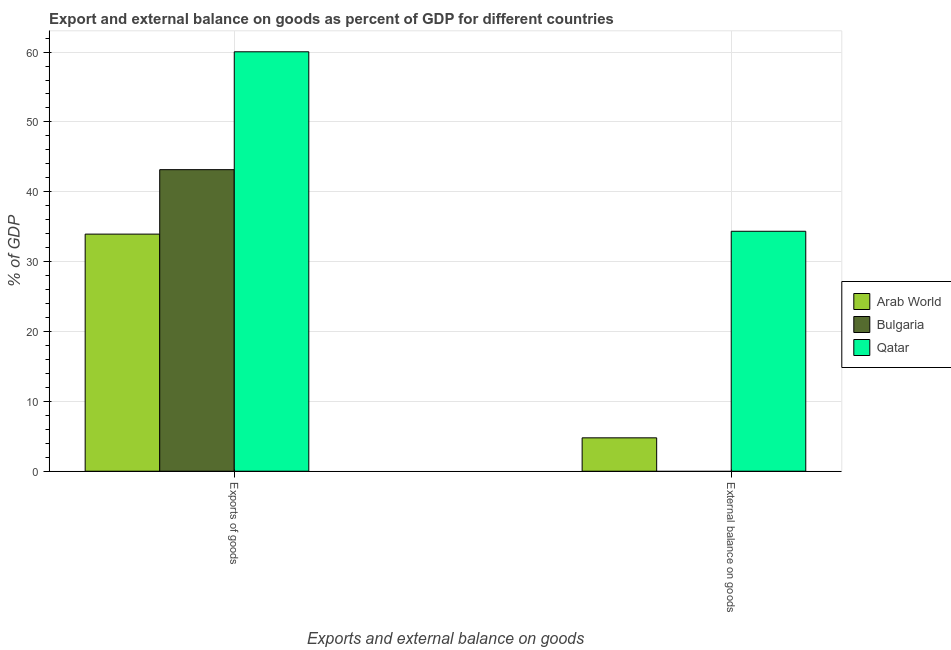How many different coloured bars are there?
Ensure brevity in your answer.  3. Are the number of bars per tick equal to the number of legend labels?
Provide a short and direct response. No. What is the label of the 1st group of bars from the left?
Offer a terse response. Exports of goods. What is the export of goods as percentage of gdp in Bulgaria?
Provide a succinct answer. 43.17. Across all countries, what is the maximum external balance on goods as percentage of gdp?
Ensure brevity in your answer.  34.35. In which country was the export of goods as percentage of gdp maximum?
Keep it short and to the point. Qatar. What is the total external balance on goods as percentage of gdp in the graph?
Your answer should be very brief. 39.13. What is the difference between the export of goods as percentage of gdp in Qatar and that in Bulgaria?
Provide a succinct answer. 16.87. What is the difference between the external balance on goods as percentage of gdp in Arab World and the export of goods as percentage of gdp in Bulgaria?
Make the answer very short. -38.39. What is the average export of goods as percentage of gdp per country?
Provide a short and direct response. 45.72. What is the difference between the external balance on goods as percentage of gdp and export of goods as percentage of gdp in Qatar?
Provide a short and direct response. -25.69. In how many countries, is the external balance on goods as percentage of gdp greater than 32 %?
Give a very brief answer. 1. What is the ratio of the export of goods as percentage of gdp in Arab World to that in Bulgaria?
Give a very brief answer. 0.79. Are the values on the major ticks of Y-axis written in scientific E-notation?
Provide a succinct answer. No. Does the graph contain any zero values?
Make the answer very short. Yes. How many legend labels are there?
Your answer should be very brief. 3. How are the legend labels stacked?
Provide a succinct answer. Vertical. What is the title of the graph?
Provide a short and direct response. Export and external balance on goods as percent of GDP for different countries. What is the label or title of the X-axis?
Your answer should be very brief. Exports and external balance on goods. What is the label or title of the Y-axis?
Offer a very short reply. % of GDP. What is the % of GDP of Arab World in Exports of goods?
Ensure brevity in your answer.  33.94. What is the % of GDP in Bulgaria in Exports of goods?
Provide a short and direct response. 43.17. What is the % of GDP of Qatar in Exports of goods?
Your response must be concise. 60.04. What is the % of GDP in Arab World in External balance on goods?
Give a very brief answer. 4.78. What is the % of GDP in Bulgaria in External balance on goods?
Offer a terse response. 0. What is the % of GDP of Qatar in External balance on goods?
Provide a succinct answer. 34.35. Across all Exports and external balance on goods, what is the maximum % of GDP in Arab World?
Your response must be concise. 33.94. Across all Exports and external balance on goods, what is the maximum % of GDP of Bulgaria?
Provide a succinct answer. 43.17. Across all Exports and external balance on goods, what is the maximum % of GDP of Qatar?
Offer a terse response. 60.04. Across all Exports and external balance on goods, what is the minimum % of GDP of Arab World?
Your response must be concise. 4.78. Across all Exports and external balance on goods, what is the minimum % of GDP in Qatar?
Your answer should be compact. 34.35. What is the total % of GDP of Arab World in the graph?
Your answer should be compact. 38.72. What is the total % of GDP of Bulgaria in the graph?
Provide a succinct answer. 43.17. What is the total % of GDP of Qatar in the graph?
Your answer should be very brief. 94.39. What is the difference between the % of GDP of Arab World in Exports of goods and that in External balance on goods?
Provide a short and direct response. 29.16. What is the difference between the % of GDP of Qatar in Exports of goods and that in External balance on goods?
Your answer should be very brief. 25.69. What is the difference between the % of GDP in Arab World in Exports of goods and the % of GDP in Qatar in External balance on goods?
Provide a short and direct response. -0.41. What is the difference between the % of GDP in Bulgaria in Exports of goods and the % of GDP in Qatar in External balance on goods?
Keep it short and to the point. 8.82. What is the average % of GDP in Arab World per Exports and external balance on goods?
Provide a succinct answer. 19.36. What is the average % of GDP in Bulgaria per Exports and external balance on goods?
Provide a short and direct response. 21.58. What is the average % of GDP in Qatar per Exports and external balance on goods?
Your response must be concise. 47.19. What is the difference between the % of GDP in Arab World and % of GDP in Bulgaria in Exports of goods?
Provide a succinct answer. -9.23. What is the difference between the % of GDP of Arab World and % of GDP of Qatar in Exports of goods?
Offer a terse response. -26.1. What is the difference between the % of GDP in Bulgaria and % of GDP in Qatar in Exports of goods?
Provide a succinct answer. -16.87. What is the difference between the % of GDP in Arab World and % of GDP in Qatar in External balance on goods?
Ensure brevity in your answer.  -29.57. What is the ratio of the % of GDP of Arab World in Exports of goods to that in External balance on goods?
Provide a succinct answer. 7.1. What is the ratio of the % of GDP of Qatar in Exports of goods to that in External balance on goods?
Your response must be concise. 1.75. What is the difference between the highest and the second highest % of GDP in Arab World?
Your response must be concise. 29.16. What is the difference between the highest and the second highest % of GDP of Qatar?
Offer a very short reply. 25.69. What is the difference between the highest and the lowest % of GDP in Arab World?
Your answer should be compact. 29.16. What is the difference between the highest and the lowest % of GDP of Bulgaria?
Offer a very short reply. 43.17. What is the difference between the highest and the lowest % of GDP in Qatar?
Make the answer very short. 25.69. 